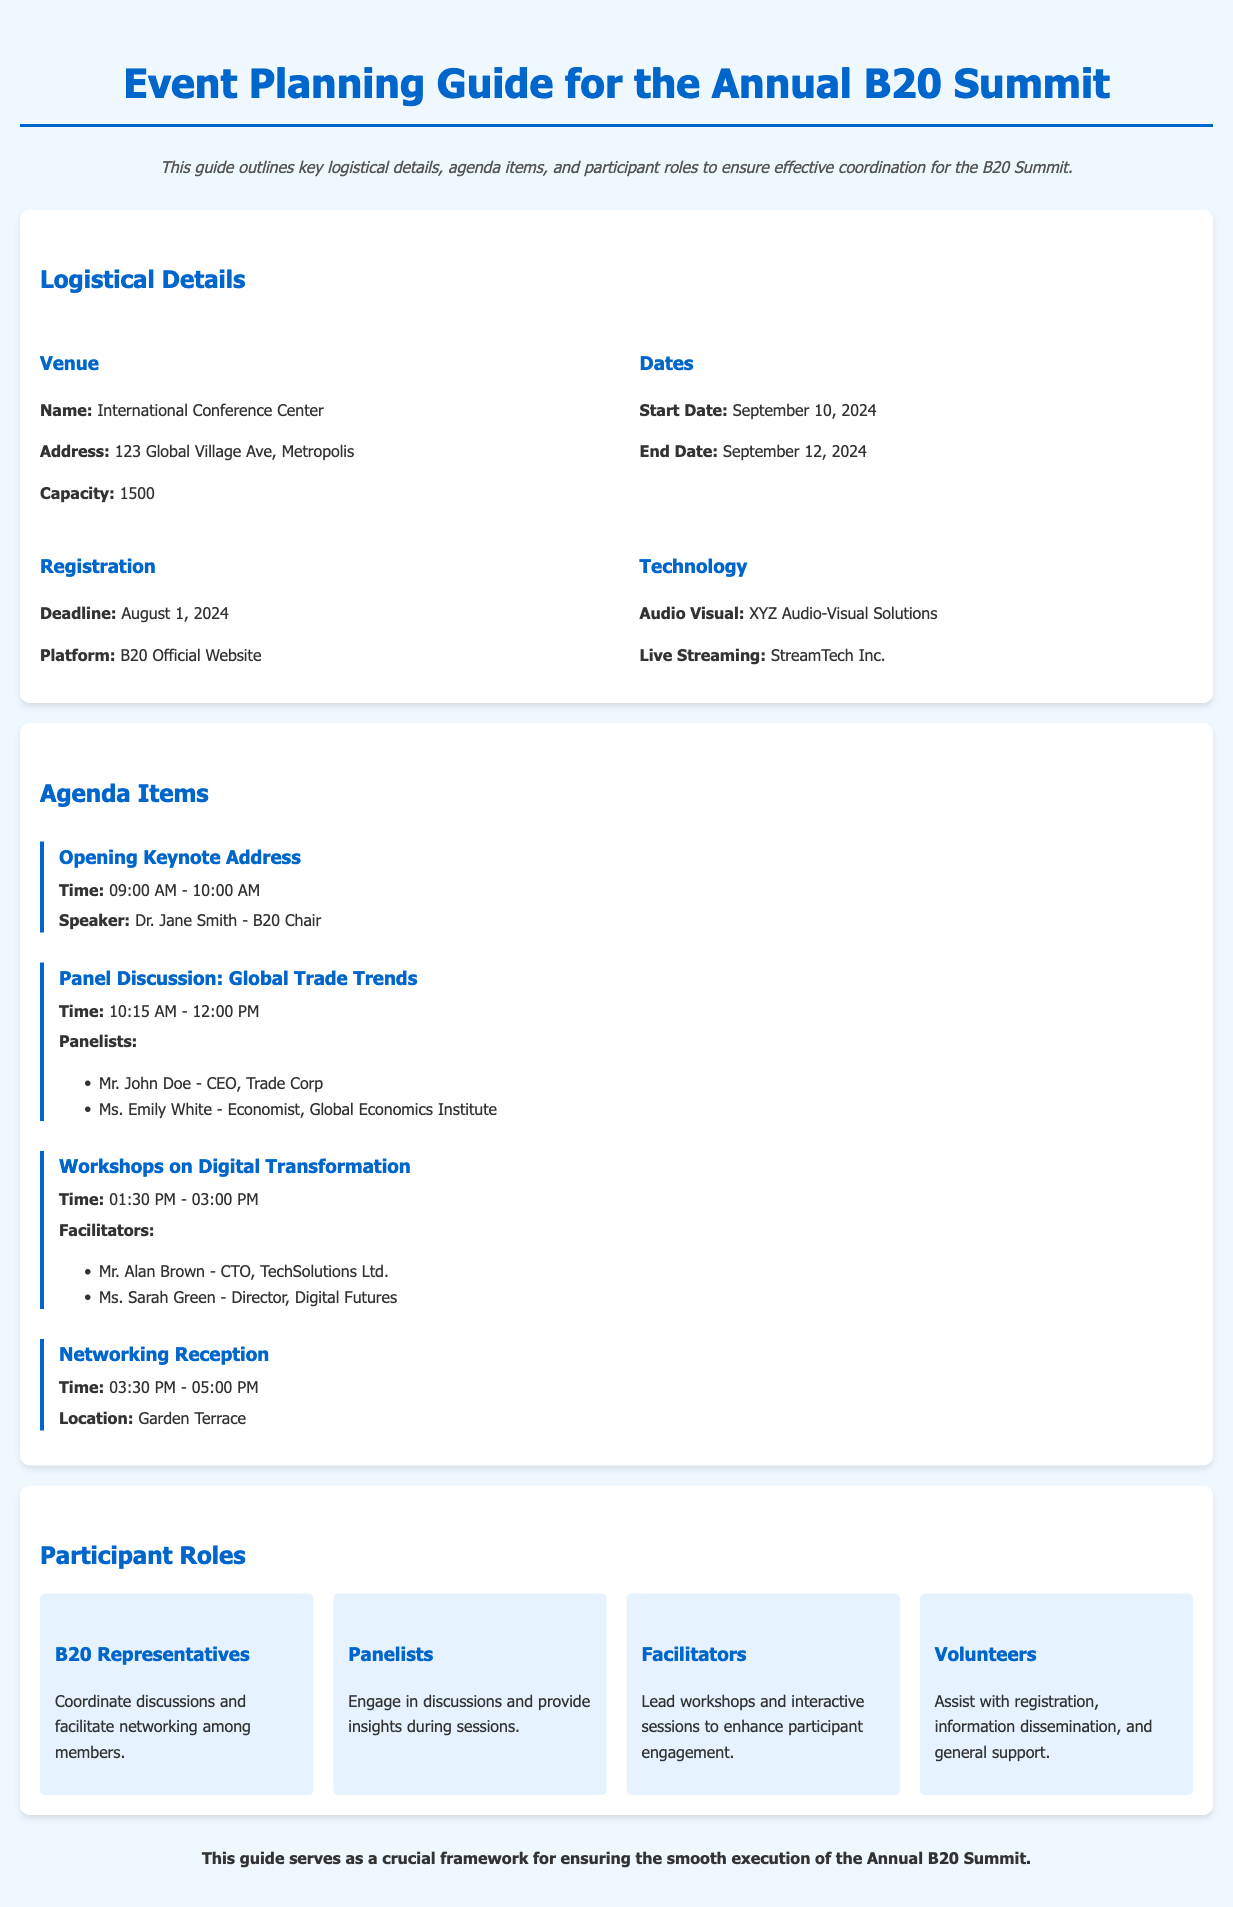What is the name of the venue? The name of the venue is listed as the International Conference Center under logistical details.
Answer: International Conference Center What is the capacity of the venue? The capacity of the venue is specified under logistical details.
Answer: 1500 When is the registration deadline? The registration deadline is stated clearly in the document under the registration section.
Answer: August 1, 2024 Who is the opening keynote speaker? The opening keynote speaker is mentioned in the agenda items section, specifically for the opening keynote address.
Answer: Dr. Jane Smith What time does the Networking Reception start? The start time for the Networking Reception is provided in the agenda items, specifying the duration.
Answer: 03:30 PM How many workshops are listed in the agenda? The number of workshops can be determined by counting the relevant agenda items in the document.
Answer: 1 What role do panelists play? The roles of panelists are outlined in the "Participant Roles" section of the document.
Answer: Engage in discussions and provide insights during sessions What is the address of the venue? The venue's address is included in the logistical details for easy reference.
Answer: 123 Global Village Ave, Metropolis Which company is responsible for live streaming? The company responsible for live streaming is mentioned under technology in the logistical details.
Answer: StreamTech Inc 